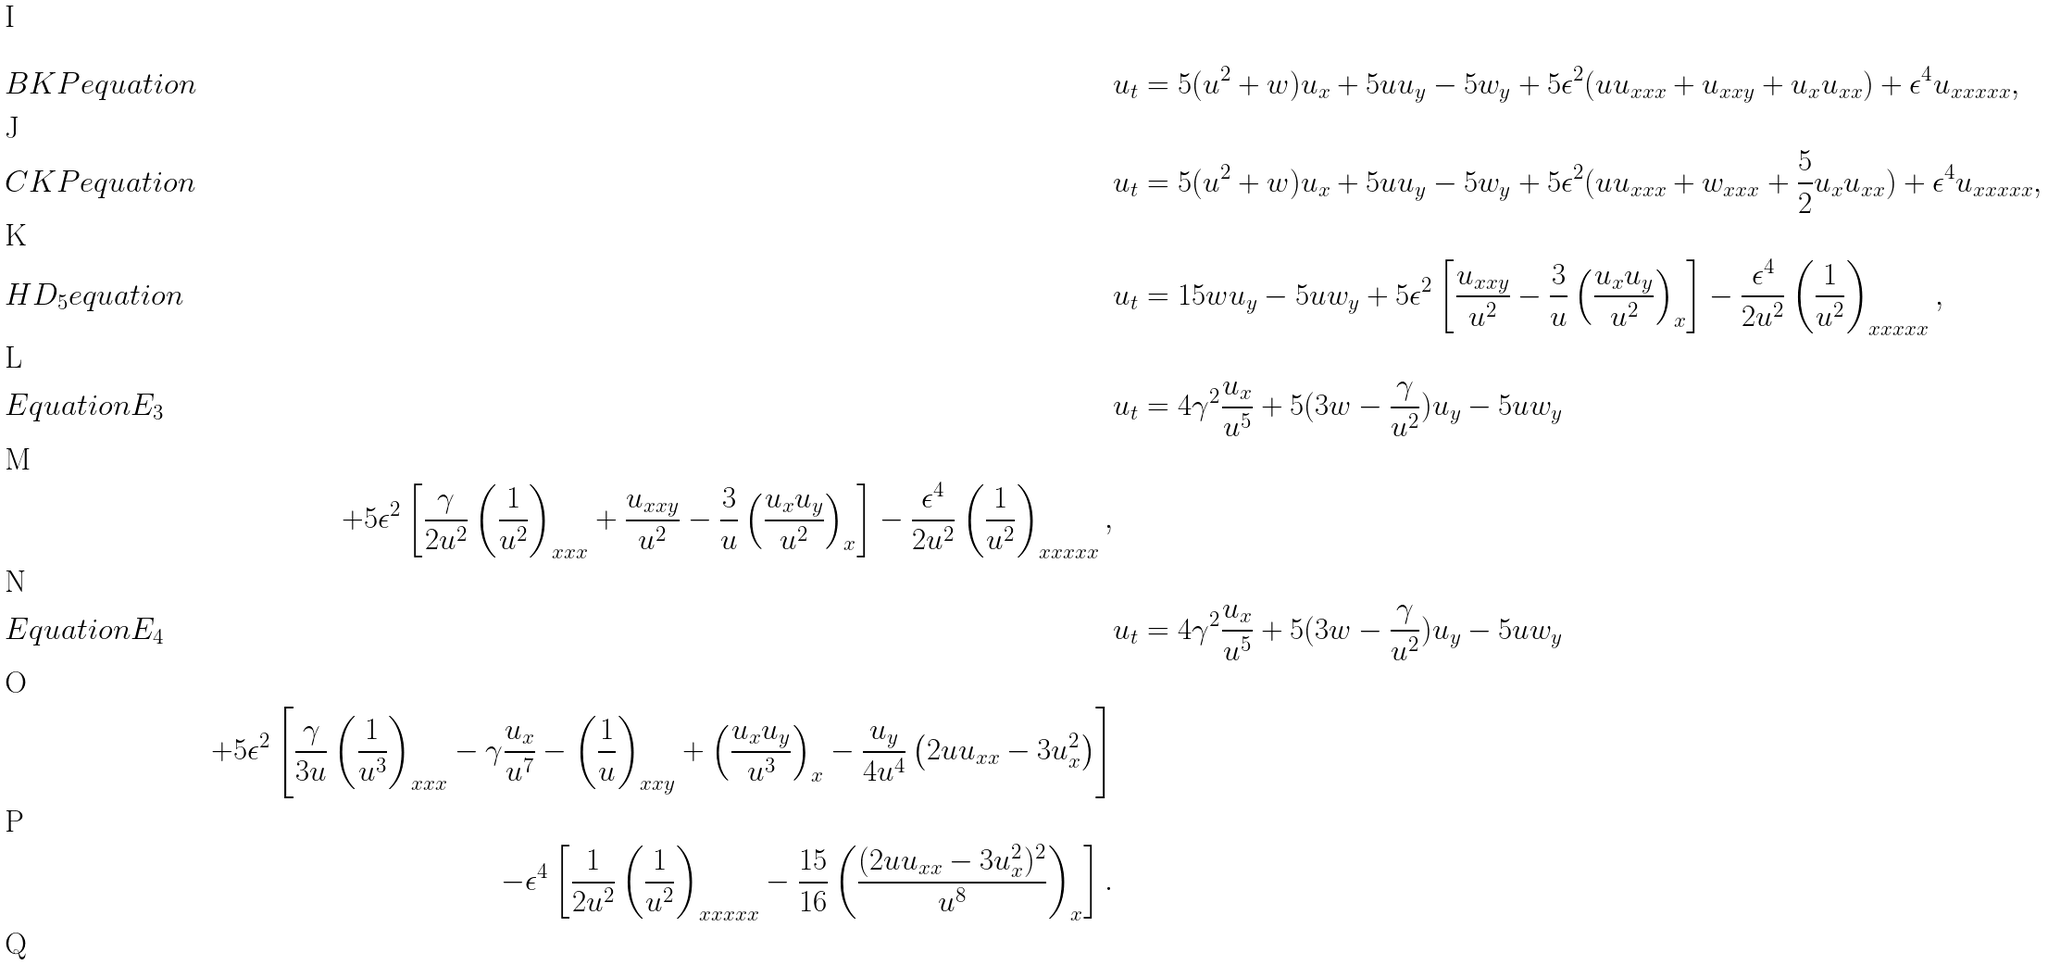Convert formula to latex. <formula><loc_0><loc_0><loc_500><loc_500>& { B K P e q u a t i o n } & \quad & u _ { t } = 5 ( u ^ { 2 } + w ) u _ { x } + 5 u u _ { y } - 5 w _ { y } + 5 \epsilon ^ { 2 } ( u u _ { x x x } + u _ { x x y } + u _ { x } u _ { x x } ) + \epsilon ^ { 4 } u _ { x x x x x } , & \\ & { C K P e q u a t i o n } & \quad & u _ { t } = 5 ( u ^ { 2 } + w ) u _ { x } + 5 u u _ { y } - 5 w _ { y } + 5 \epsilon ^ { 2 } ( u u _ { x x x } + w _ { x x x } + \frac { 5 } { 2 } u _ { x } u _ { x x } ) + \epsilon ^ { 4 } u _ { x x x x x } , & \\ & { H D _ { 5 } e q u a t i o n } & \quad & u _ { t } = 1 5 w u _ { y } - 5 u w _ { y } + 5 { \epsilon ^ { 2 } } \left [ \frac { u _ { x x y } } { u ^ { 2 } } - \frac { 3 } { u } \left ( \frac { u _ { x } u _ { y } } { u ^ { 2 } } \right ) _ { x } \right ] - \frac { \epsilon ^ { 4 } } { 2 u ^ { 2 } } \left ( \frac { 1 } { u ^ { 2 } } \right ) _ { x x x x x } , & \\ & { E q u a t i o n E _ { 3 } } & \quad & u _ { t } = 4 \gamma ^ { 2 } \frac { u _ { x } } { u ^ { 5 } } + 5 ( 3 w - \frac { \gamma } { u ^ { 2 } } ) u _ { y } - 5 u w _ { y } & \\ & \quad & + 5 \epsilon ^ { 2 } \left [ \frac { \gamma } { 2 u ^ { 2 } } \left ( \frac { 1 } { u ^ { 2 } } \right ) _ { x x x } + \frac { u _ { x x y } } { u ^ { 2 } } - \frac { 3 } { u } \left ( \frac { u _ { x } u _ { y } } { u ^ { 2 } } \right ) _ { x } \right ] - \frac { \epsilon ^ { 4 } } { 2 u ^ { 2 } } \left ( \frac { 1 } { u ^ { 2 } } \right ) _ { x x x x x } , & \\ & { E q u a t i o n E _ { 4 } } & \quad & u _ { t } = 4 \gamma ^ { 2 } \frac { u _ { x } } { u ^ { 5 } } + 5 ( 3 w - \frac { \gamma } { u ^ { 2 } } ) u _ { y } - 5 u w _ { y } & \\ & \quad & + 5 \epsilon ^ { 2 } \left [ \frac { \gamma } { 3 u } \left ( \frac { 1 } { u ^ { 3 } } \right ) _ { x x x } - \gamma \frac { u _ { x } } { u ^ { 7 } } - \left ( \frac { 1 } { u } \right ) _ { x x y } + \left ( \frac { u _ { x } u _ { y } } { u ^ { 3 } } \right ) _ { x } - \frac { u _ { y } } { 4 u ^ { 4 } } \left ( 2 u u _ { x x } - 3 u _ { x } ^ { 2 } \right ) \right ] & \\ & \quad & - \epsilon ^ { 4 } \left [ \frac { 1 } { 2 u ^ { 2 } } \left ( \frac { 1 } { u ^ { 2 } } \right ) _ { x x x x x } - \frac { 1 5 } { 1 6 } \left ( \frac { ( 2 u u _ { x x } - 3 u _ { x } ^ { 2 } ) ^ { 2 } } { u ^ { 8 } } \right ) _ { x } \right ] . & \\</formula> 